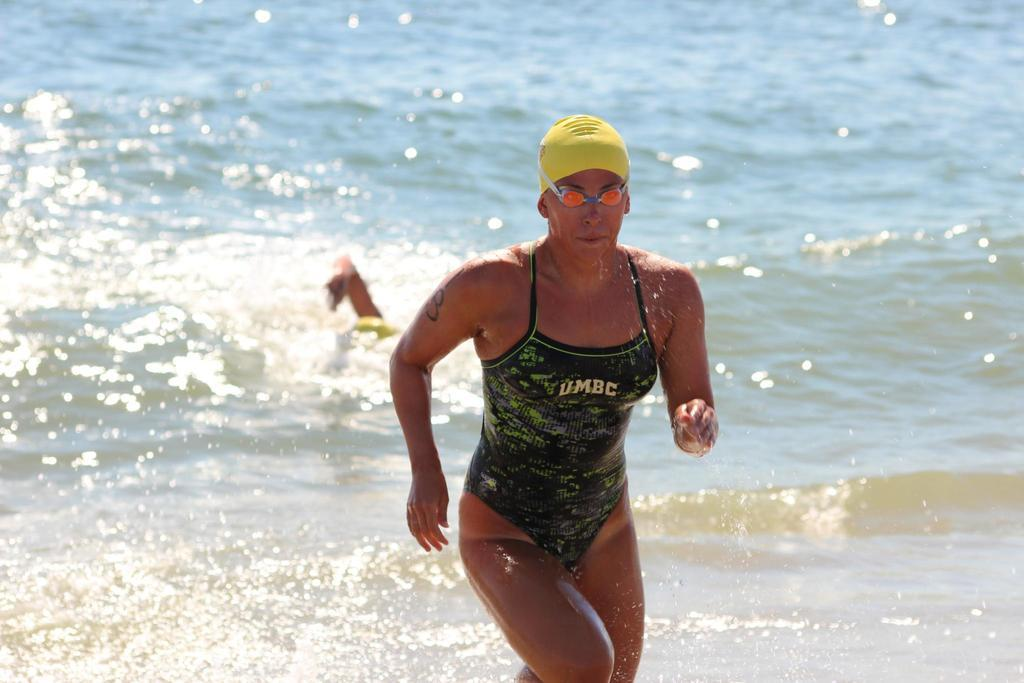Who is the main subject in the image? There is a woman in the image. What is the woman doing in the image? The woman is running. What is unusual about the woman's running in the image? The woman appears to be running on water. What can be seen in the background of the image? The background of the image is water. What type of iron can be seen in the alley in the image? There is no iron or alley present in the image; it features a woman running on water. How many sticks are visible in the image? There are no sticks visible in the image. 